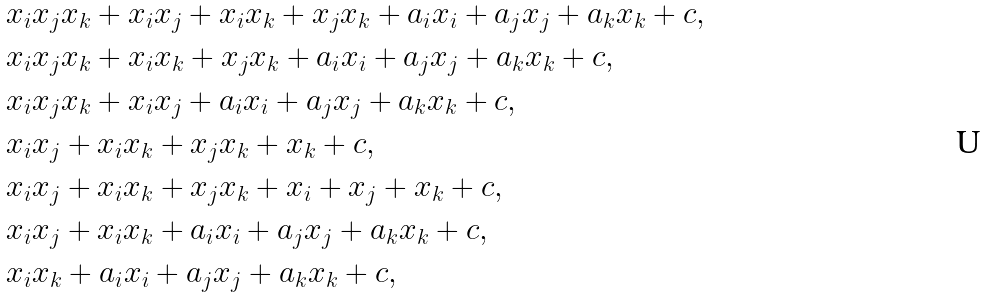<formula> <loc_0><loc_0><loc_500><loc_500>& x _ { i } x _ { j } x _ { k } + x _ { i } x _ { j } + x _ { i } x _ { k } + x _ { j } x _ { k } + a _ { i } x _ { i } + a _ { j } x _ { j } + a _ { k } x _ { k } + c , \\ & x _ { i } x _ { j } x _ { k } + x _ { i } x _ { k } + x _ { j } x _ { k } + a _ { i } x _ { i } + a _ { j } x _ { j } + a _ { k } x _ { k } + c , \\ & x _ { i } x _ { j } x _ { k } + x _ { i } x _ { j } + a _ { i } x _ { i } + a _ { j } x _ { j } + a _ { k } x _ { k } + c , \\ & x _ { i } x _ { j } + x _ { i } x _ { k } + x _ { j } x _ { k } + x _ { k } + c , \\ & x _ { i } x _ { j } + x _ { i } x _ { k } + x _ { j } x _ { k } + x _ { i } + x _ { j } + x _ { k } + c , \\ & x _ { i } x _ { j } + x _ { i } x _ { k } + a _ { i } x _ { i } + a _ { j } x _ { j } + a _ { k } x _ { k } + c , \\ & x _ { i } x _ { k } + a _ { i } x _ { i } + a _ { j } x _ { j } + a _ { k } x _ { k } + c ,</formula> 